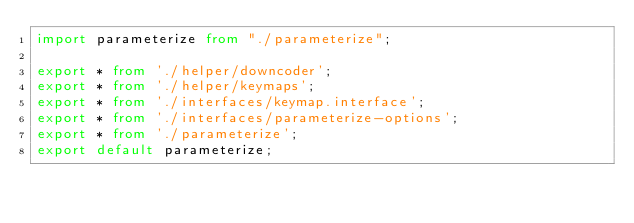<code> <loc_0><loc_0><loc_500><loc_500><_TypeScript_>import parameterize from "./parameterize";

export * from './helper/downcoder';
export * from './helper/keymaps';
export * from './interfaces/keymap.interface';
export * from './interfaces/parameterize-options';
export * from './parameterize';
export default parameterize;
</code> 